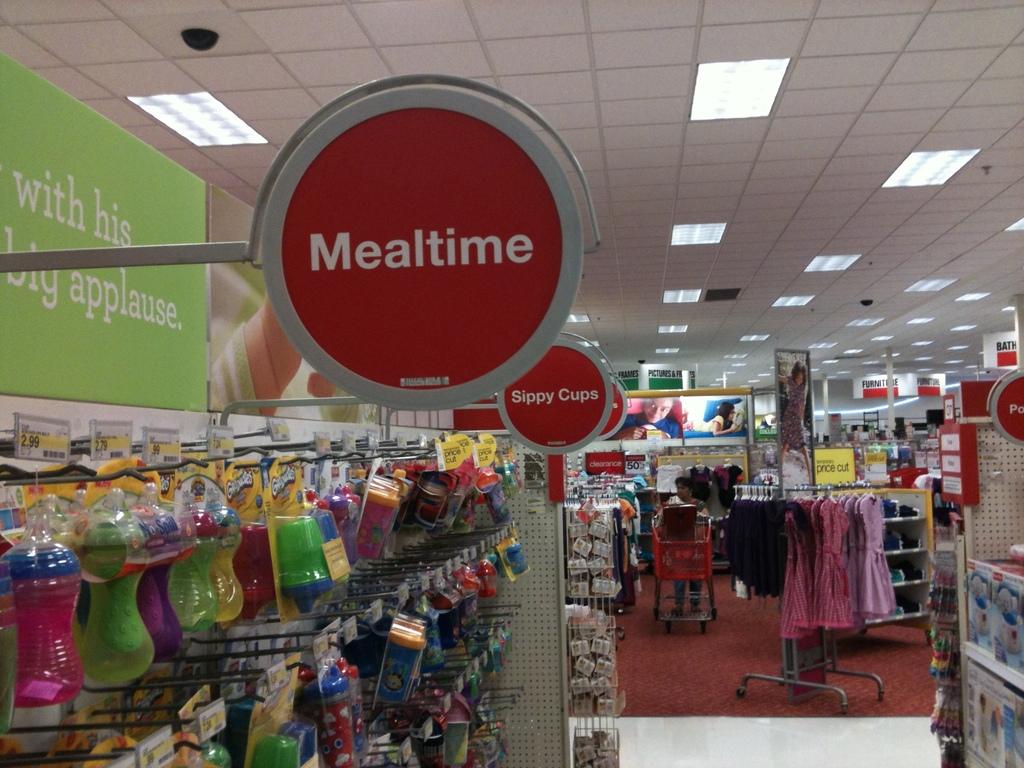What does the closest red sign say?
Provide a short and direct response. Mealtime. What does the sign say behind the mealtime sign?
Your response must be concise. Sippy cups. 